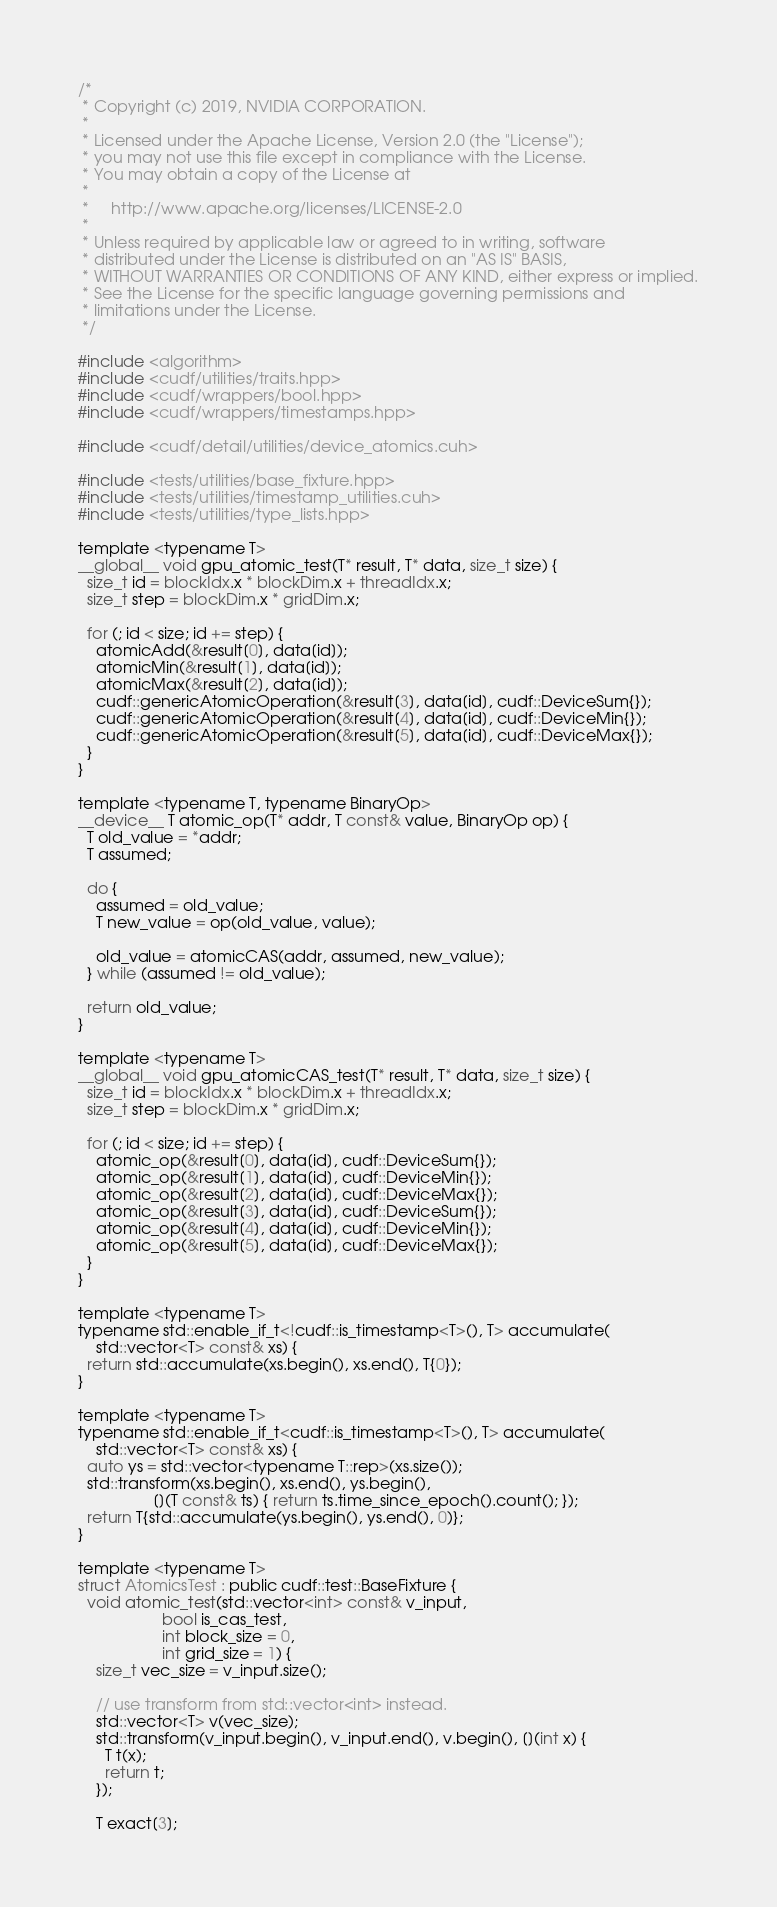<code> <loc_0><loc_0><loc_500><loc_500><_Cuda_>/*
 * Copyright (c) 2019, NVIDIA CORPORATION.
 *
 * Licensed under the Apache License, Version 2.0 (the "License");
 * you may not use this file except in compliance with the License.
 * You may obtain a copy of the License at
 *
 *     http://www.apache.org/licenses/LICENSE-2.0
 *
 * Unless required by applicable law or agreed to in writing, software
 * distributed under the License is distributed on an "AS IS" BASIS,
 * WITHOUT WARRANTIES OR CONDITIONS OF ANY KIND, either express or implied.
 * See the License for the specific language governing permissions and
 * limitations under the License.
 */

#include <algorithm>
#include <cudf/utilities/traits.hpp>
#include <cudf/wrappers/bool.hpp>
#include <cudf/wrappers/timestamps.hpp>

#include <cudf/detail/utilities/device_atomics.cuh>

#include <tests/utilities/base_fixture.hpp>
#include <tests/utilities/timestamp_utilities.cuh>
#include <tests/utilities/type_lists.hpp>

template <typename T>
__global__ void gpu_atomic_test(T* result, T* data, size_t size) {
  size_t id = blockIdx.x * blockDim.x + threadIdx.x;
  size_t step = blockDim.x * gridDim.x;

  for (; id < size; id += step) {
    atomicAdd(&result[0], data[id]);
    atomicMin(&result[1], data[id]);
    atomicMax(&result[2], data[id]);
    cudf::genericAtomicOperation(&result[3], data[id], cudf::DeviceSum{});
    cudf::genericAtomicOperation(&result[4], data[id], cudf::DeviceMin{});
    cudf::genericAtomicOperation(&result[5], data[id], cudf::DeviceMax{});
  }
}

template <typename T, typename BinaryOp>
__device__ T atomic_op(T* addr, T const& value, BinaryOp op) {
  T old_value = *addr;
  T assumed;

  do {
    assumed = old_value;
    T new_value = op(old_value, value);

    old_value = atomicCAS(addr, assumed, new_value);
  } while (assumed != old_value);

  return old_value;
}

template <typename T>
__global__ void gpu_atomicCAS_test(T* result, T* data, size_t size) {
  size_t id = blockIdx.x * blockDim.x + threadIdx.x;
  size_t step = blockDim.x * gridDim.x;

  for (; id < size; id += step) {
    atomic_op(&result[0], data[id], cudf::DeviceSum{});
    atomic_op(&result[1], data[id], cudf::DeviceMin{});
    atomic_op(&result[2], data[id], cudf::DeviceMax{});
    atomic_op(&result[3], data[id], cudf::DeviceSum{});
    atomic_op(&result[4], data[id], cudf::DeviceMin{});
    atomic_op(&result[5], data[id], cudf::DeviceMax{});
  }
}

template <typename T>
typename std::enable_if_t<!cudf::is_timestamp<T>(), T> accumulate(
    std::vector<T> const& xs) {
  return std::accumulate(xs.begin(), xs.end(), T{0});
}

template <typename T>
typename std::enable_if_t<cudf::is_timestamp<T>(), T> accumulate(
    std::vector<T> const& xs) {
  auto ys = std::vector<typename T::rep>(xs.size());
  std::transform(xs.begin(), xs.end(), ys.begin(),
                 [](T const& ts) { return ts.time_since_epoch().count(); });
  return T{std::accumulate(ys.begin(), ys.end(), 0)};
}

template <typename T>
struct AtomicsTest : public cudf::test::BaseFixture {
  void atomic_test(std::vector<int> const& v_input,
                   bool is_cas_test,
                   int block_size = 0,
                   int grid_size = 1) {
    size_t vec_size = v_input.size();

    // use transform from std::vector<int> instead.
    std::vector<T> v(vec_size);
    std::transform(v_input.begin(), v_input.end(), v.begin(), [](int x) {
      T t(x);
      return t;
    });

    T exact[3];</code> 